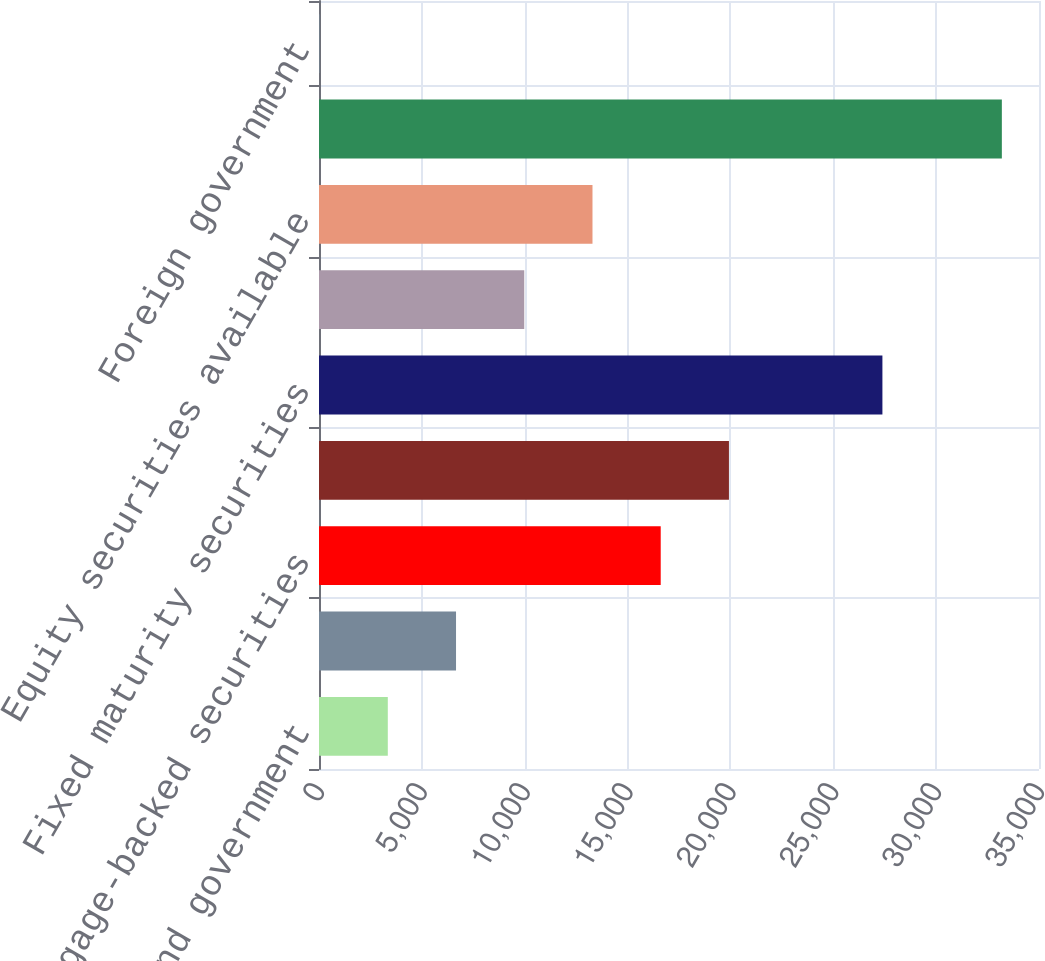Convert chart to OTSL. <chart><loc_0><loc_0><loc_500><loc_500><bar_chart><fcel>US government and government<fcel>State and municipal<fcel>Mortgage-backed securities<fcel>Corporate<fcel>Fixed maturity securities<fcel>Preferred stocks<fcel>Equity securities available<fcel>Total<fcel>Foreign government<nl><fcel>3344.6<fcel>6661.2<fcel>16611<fcel>19927.6<fcel>27388<fcel>9977.8<fcel>13294.4<fcel>33194<fcel>28<nl></chart> 